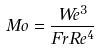<formula> <loc_0><loc_0><loc_500><loc_500>M o = \frac { W e ^ { 3 } } { F r R e ^ { 4 } }</formula> 